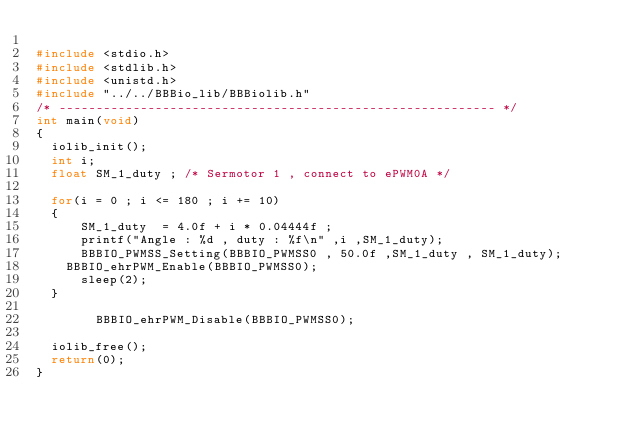<code> <loc_0><loc_0><loc_500><loc_500><_C_>
#include <stdio.h>
#include <stdlib.h>
#include <unistd.h>
#include "../../BBBio_lib/BBBiolib.h"
/* ----------------------------------------------------------- */
int main(void)
{
	iolib_init();
	int i;
	float SM_1_duty ;	/* Sermotor 1 , connect to ePWM0A */

	for(i = 0 ; i <= 180 ; i += 10)
	{
	    SM_1_duty  = 4.0f + i * 0.04444f ;
	    printf("Angle : %d , duty : %f\n" ,i ,SM_1_duty);
	    BBBIO_PWMSS_Setting(BBBIO_PWMSS0 , 50.0f ,SM_1_duty , SM_1_duty);
		BBBIO_ehrPWM_Enable(BBBIO_PWMSS0);
	    sleep(2);
	}

        BBBIO_ehrPWM_Disable(BBBIO_PWMSS0);

	iolib_free();
	return(0);
}


</code> 